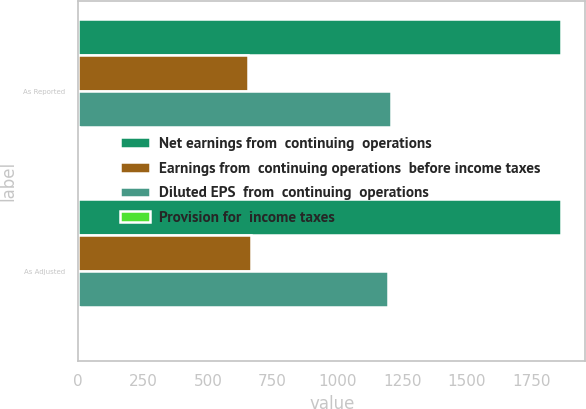Convert chart to OTSL. <chart><loc_0><loc_0><loc_500><loc_500><stacked_bar_chart><ecel><fcel>As Reported<fcel>As Adjusted<nl><fcel>Net earnings from  continuing  operations<fcel>1863.2<fcel>1863.2<nl><fcel>Earnings from  continuing operations  before income taxes<fcel>655.9<fcel>668.1<nl><fcel>Diluted EPS  from  continuing  operations<fcel>1207.3<fcel>1195.1<nl><fcel>Provision for  income taxes<fcel>2.4<fcel>2.37<nl></chart> 